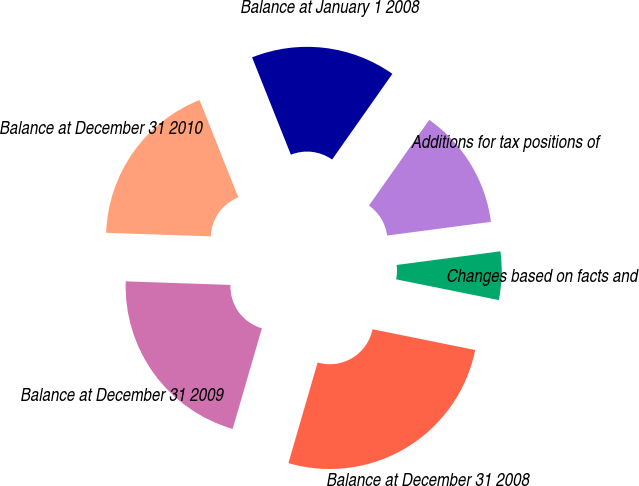Convert chart to OTSL. <chart><loc_0><loc_0><loc_500><loc_500><pie_chart><fcel>Balance at January 1 2008<fcel>Additions for tax positions of<fcel>Changes based on facts and<fcel>Balance at December 31 2008<fcel>Balance at December 31 2009<fcel>Balance at December 31 2010<nl><fcel>15.79%<fcel>13.16%<fcel>5.26%<fcel>26.32%<fcel>21.05%<fcel>18.42%<nl></chart> 